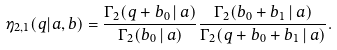<formula> <loc_0><loc_0><loc_500><loc_500>\eta _ { 2 , 1 } ( q | a , b ) = \frac { \Gamma _ { 2 } ( q + b _ { 0 } \, | \, a ) } { \Gamma _ { 2 } ( b _ { 0 } \, | \, a ) } \frac { \Gamma _ { 2 } ( b _ { 0 } + b _ { 1 } \, | \, a ) } { \Gamma _ { 2 } ( q + b _ { 0 } + b _ { 1 } \, | \, a ) } .</formula> 